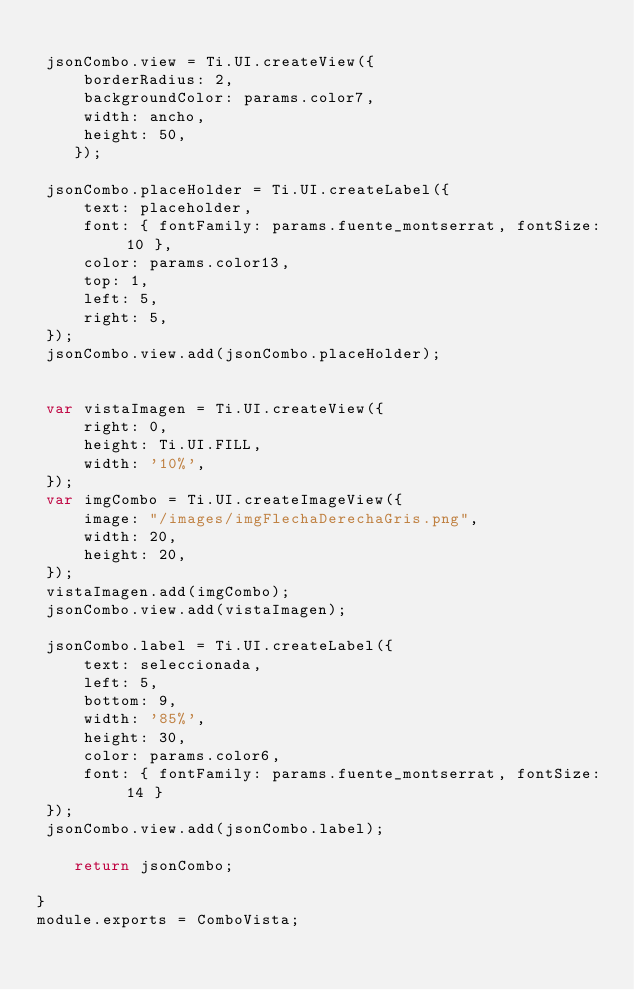<code> <loc_0><loc_0><loc_500><loc_500><_JavaScript_>
 jsonCombo.view = Ti.UI.createView({
     borderRadius: 2,
     backgroundColor: params.color7,
     width: ancho,
     height: 50,
	});
	
 jsonCombo.placeHolder = Ti.UI.createLabel({
     text: placeholder,
     font: { fontFamily: params.fuente_montserrat, fontSize: 10 },
     color: params.color13,
     top: 1,
     left: 5,
     right: 5,
 });
 jsonCombo.view.add(jsonCombo.placeHolder);
	
 
 var vistaImagen = Ti.UI.createView({
     right: 0,
     height: Ti.UI.FILL,
     width: '10%',
 });
 var imgCombo = Ti.UI.createImageView({
     image: "/images/imgFlechaDerechaGris.png",
     width: 20,
     height: 20,
 }); 
 vistaImagen.add(imgCombo);
 jsonCombo.view.add(vistaImagen);
 
 jsonCombo.label = Ti.UI.createLabel({
     text: seleccionada,
     left: 5,
     bottom: 9,
     width: '85%',
     height: 30,
     color: params.color6,
     font: { fontFamily: params.fuente_montserrat, fontSize: 14 }
 });
 jsonCombo.view.add(jsonCombo.label);
 
	return jsonCombo;

}
module.exports = ComboVista;</code> 